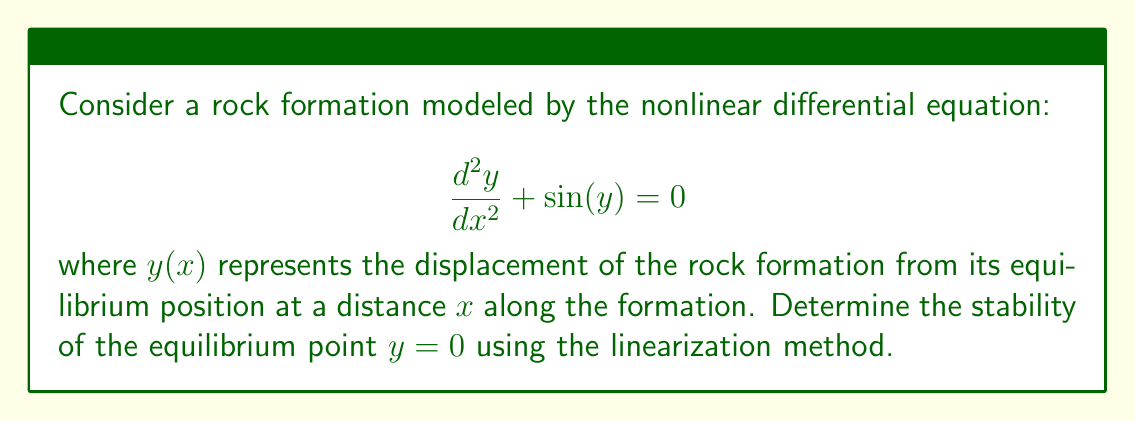Could you help me with this problem? 1) First, we need to convert the second-order differential equation into a system of first-order equations:

   Let $y_1 = y$ and $y_2 = \frac{dy}{dx}$

   Then, $\frac{dy_1}{dx} = y_2$ and $\frac{dy_2}{dx} = -\sin(y_1)$

2) The equilibrium point is $(y_1, y_2) = (0, 0)$

3) To linearize the system, we need to calculate the Jacobian matrix at the equilibrium point:

   $J = \begin{bmatrix}
   \frac{\partial}{\partial y_1}(y_2) & \frac{\partial}{\partial y_2}(y_2) \\
   \frac{\partial}{\partial y_1}(-\sin(y_1)) & \frac{\partial}{\partial y_2}(-\sin(y_1))
   \end{bmatrix}$

   $J = \begin{bmatrix}
   0 & 1 \\
   -\cos(y_1) & 0
   \end{bmatrix}$

4) At the equilibrium point $(0, 0)$:

   $J_{(0,0)} = \begin{bmatrix}
   0 & 1 \\
   -1 & 0
   \end{bmatrix}$

5) The eigenvalues of this matrix are given by the characteristic equation:

   $\det(J_{(0,0)} - \lambda I) = 0$

   $\begin{vmatrix}
   -\lambda & 1 \\
   -1 & -\lambda
   \end{vmatrix} = 0$

   $\lambda^2 + 1 = 0$

6) Solving this equation:

   $\lambda = \pm i$

7) Since the real parts of both eigenvalues are zero, the equilibrium point is a center. This means it is neutrally stable.
Answer: Neutrally stable (center) 